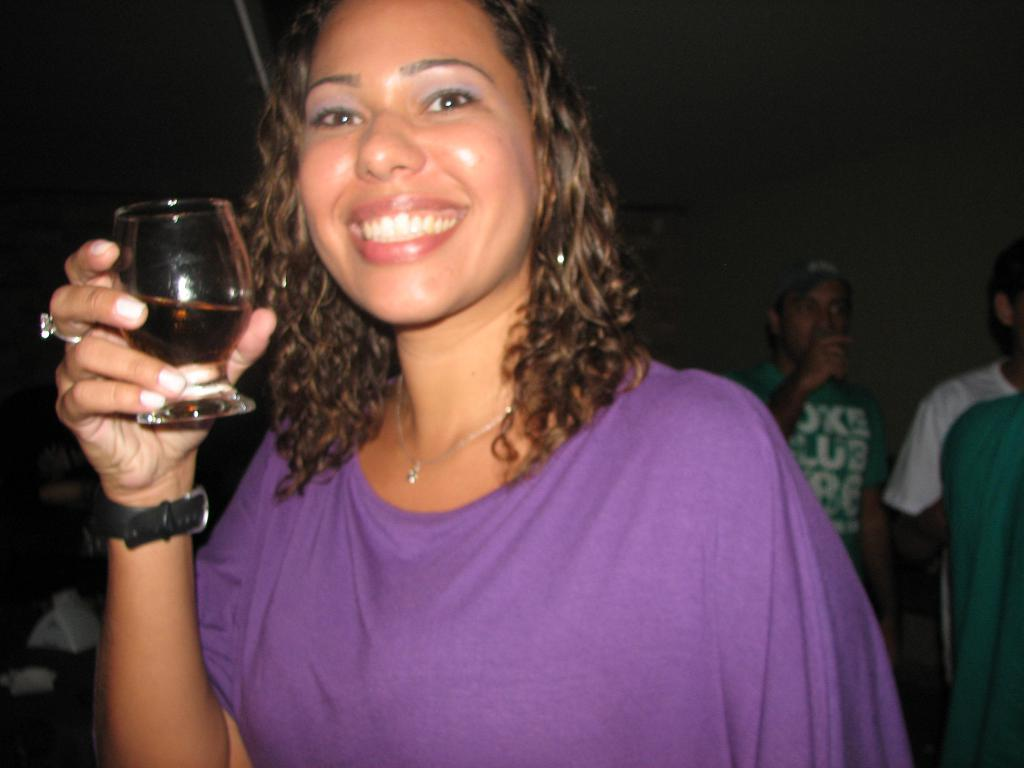What color is the t-shirt worn by the woman in the image? The woman is wearing a purple t-shirt. What is the woman holding in the image? The woman is holding a glass with liquid. What is the facial expression of the woman in the image? The woman is smiling. Can you describe the other people in the image? There are persons standing in the image. What type of celery is being used as a decoration in the image? There is no celery present in the image. Where is the camp located in the image? There is no camp present in the image. 